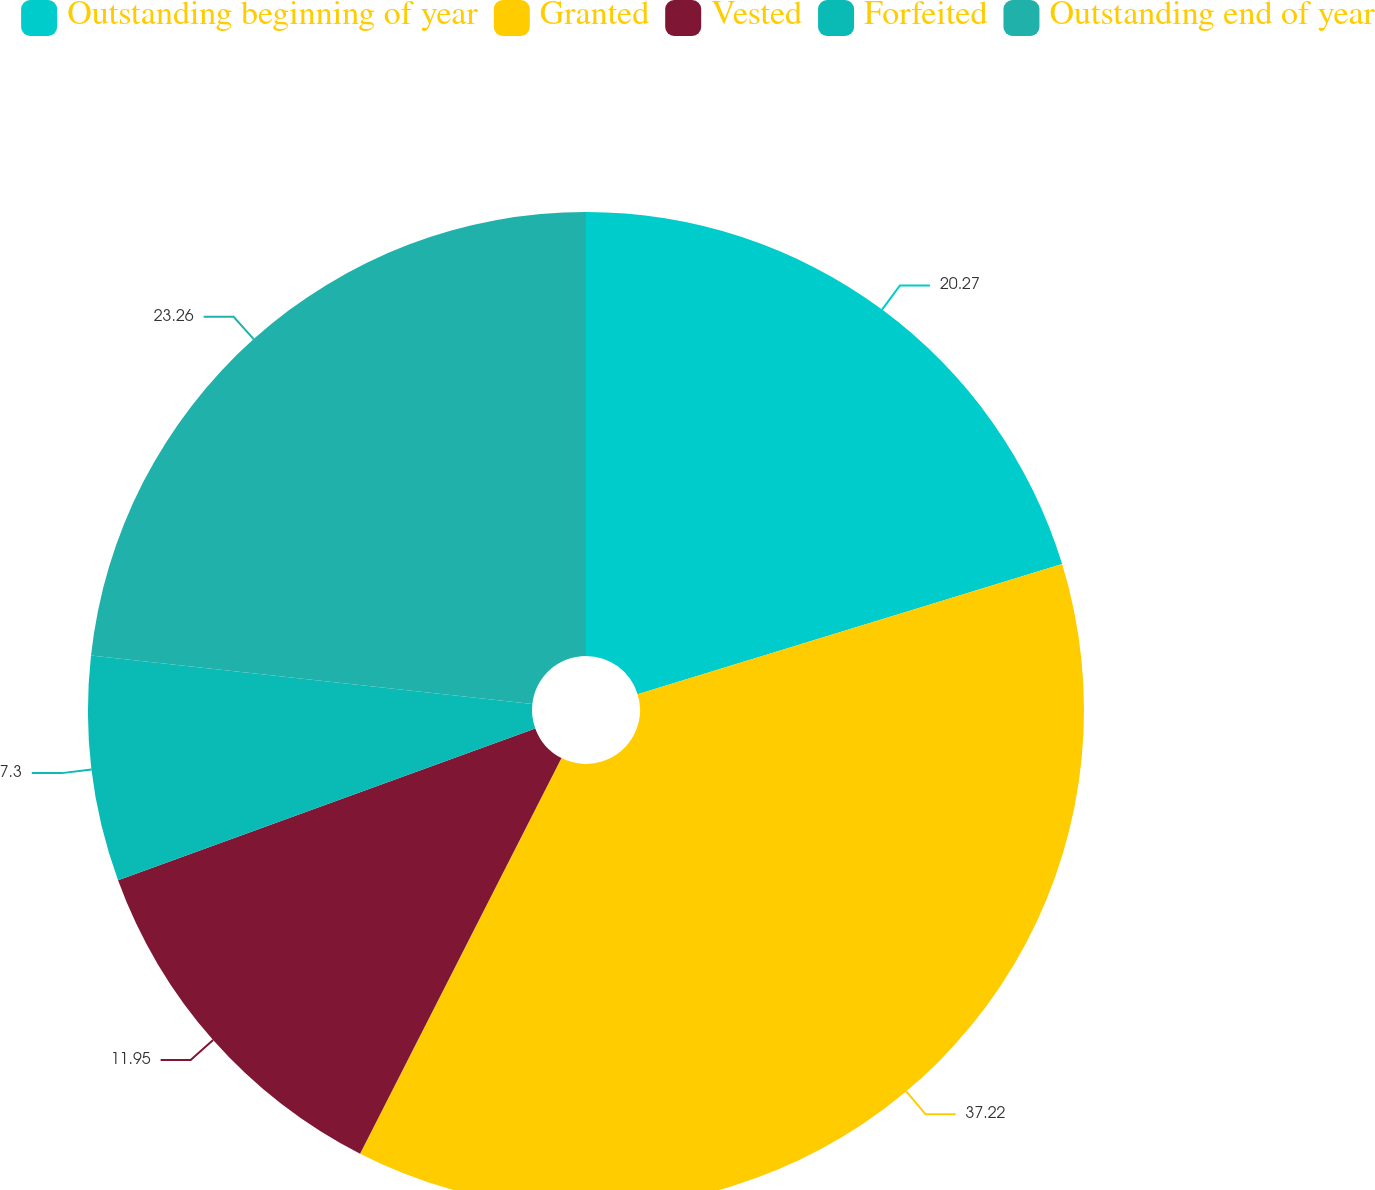Convert chart. <chart><loc_0><loc_0><loc_500><loc_500><pie_chart><fcel>Outstanding beginning of year<fcel>Granted<fcel>Vested<fcel>Forfeited<fcel>Outstanding end of year<nl><fcel>20.27%<fcel>37.23%<fcel>11.95%<fcel>7.3%<fcel>23.26%<nl></chart> 